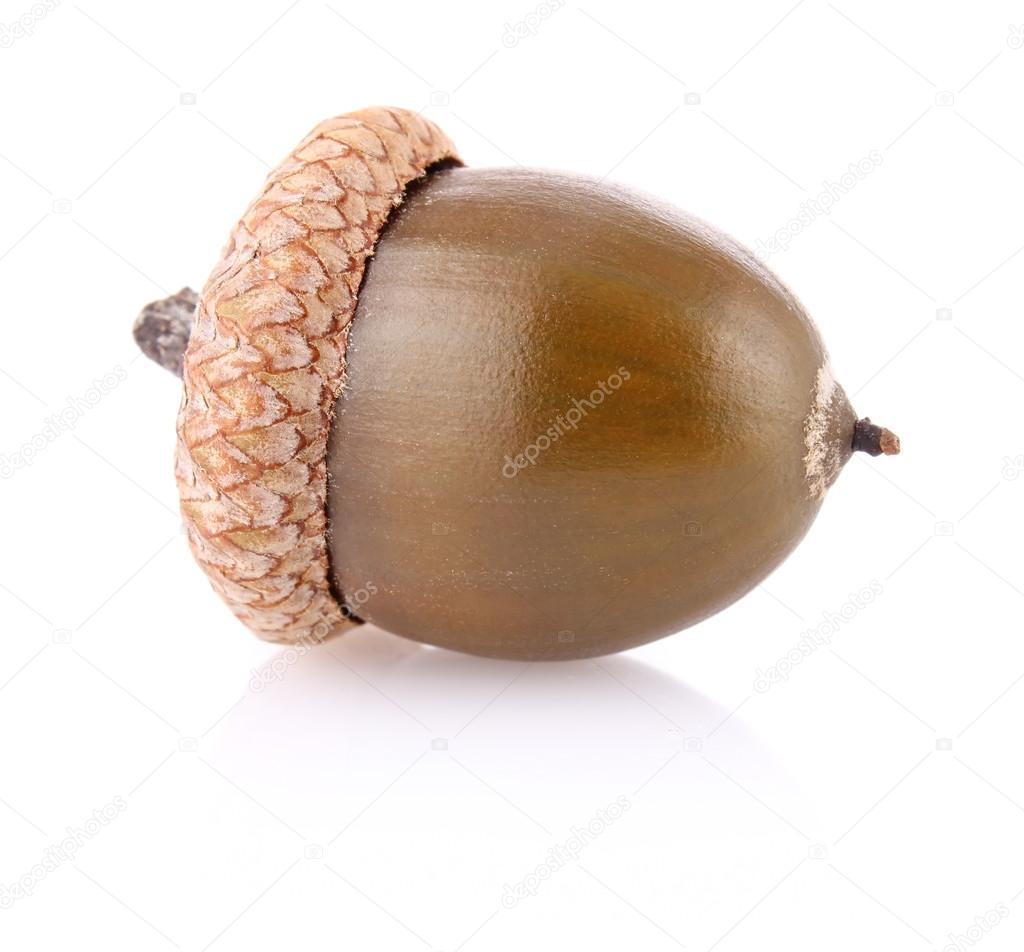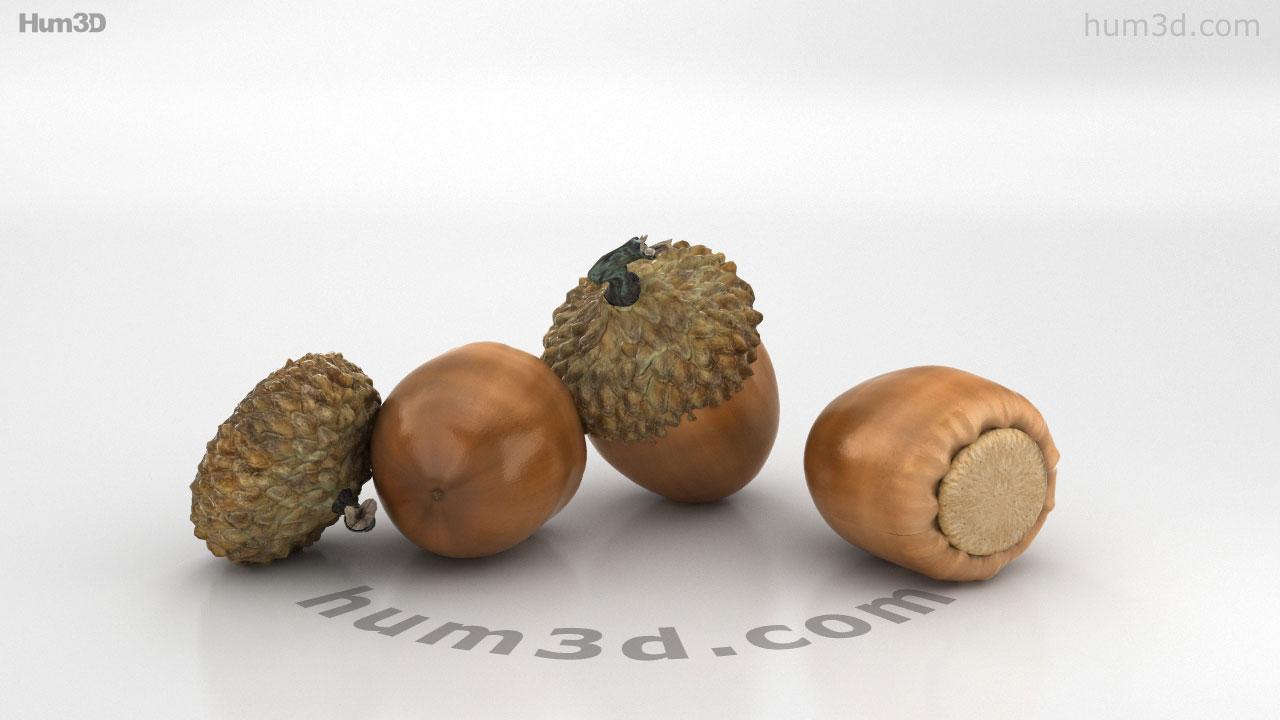The first image is the image on the left, the second image is the image on the right. Evaluate the accuracy of this statement regarding the images: "There are more items in the right image than in the left image.". Is it true? Answer yes or no. Yes. The first image is the image on the left, the second image is the image on the right. Considering the images on both sides, is "One picture shows at least three acorns next to each other." valid? Answer yes or no. Yes. 